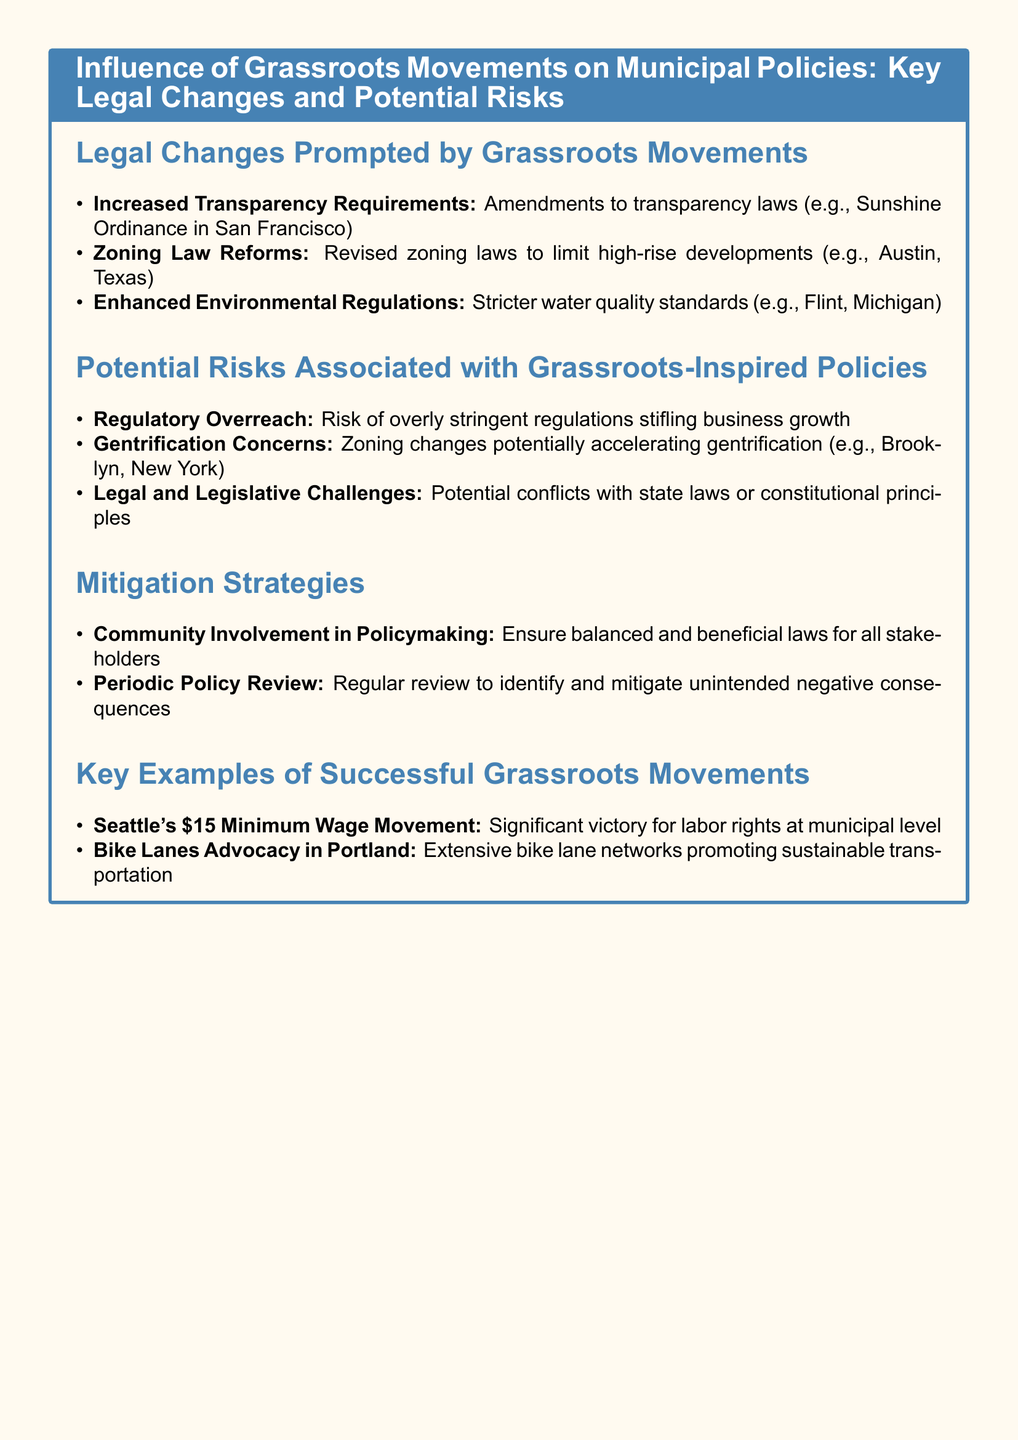What type of legal changes are influenced by grassroots movements? The document lists specific legal changes prompted by grassroots movements, such as increased transparency requirements, zoning law reforms, and enhanced environmental regulations.
Answer: Increased transparency requirements What is a key example of a successful grassroots movement? The document provides examples of successful grassroots movements, including Seattle's $15 Minimum Wage Movement and Bike Lanes Advocacy in Portland.
Answer: Seattle's $15 Minimum Wage Movement What risk is associated with zoning law reforms? The document mentions potential risks linked to grassroots-inspired policies, specifically zoning changes that could lead to gentrification.
Answer: Gentrification concerns What is one mitigation strategy mentioned in the document? The document outlines strategies to mitigate risks associated with grassroots movements, including community involvement in policymaking and periodic policy review.
Answer: Community involvement in policymaking What city was mentioned regarding enhanced environmental regulations? The document provides an example of enhanced environmental regulations that were implemented as a result of grassroots movements, specifically in Flint, Michigan.
Answer: Flint, Michigan 